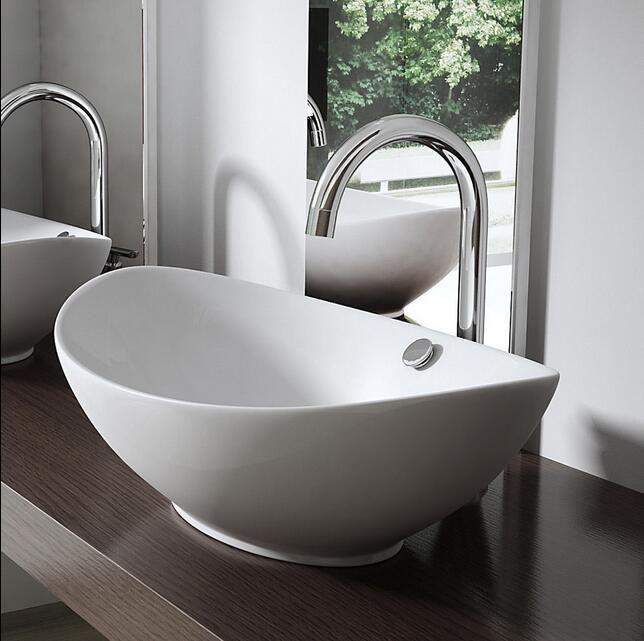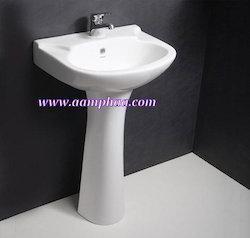The first image is the image on the left, the second image is the image on the right. Given the left and right images, does the statement "Greenery can be seen past the sink on the left." hold true? Answer yes or no. Yes. 